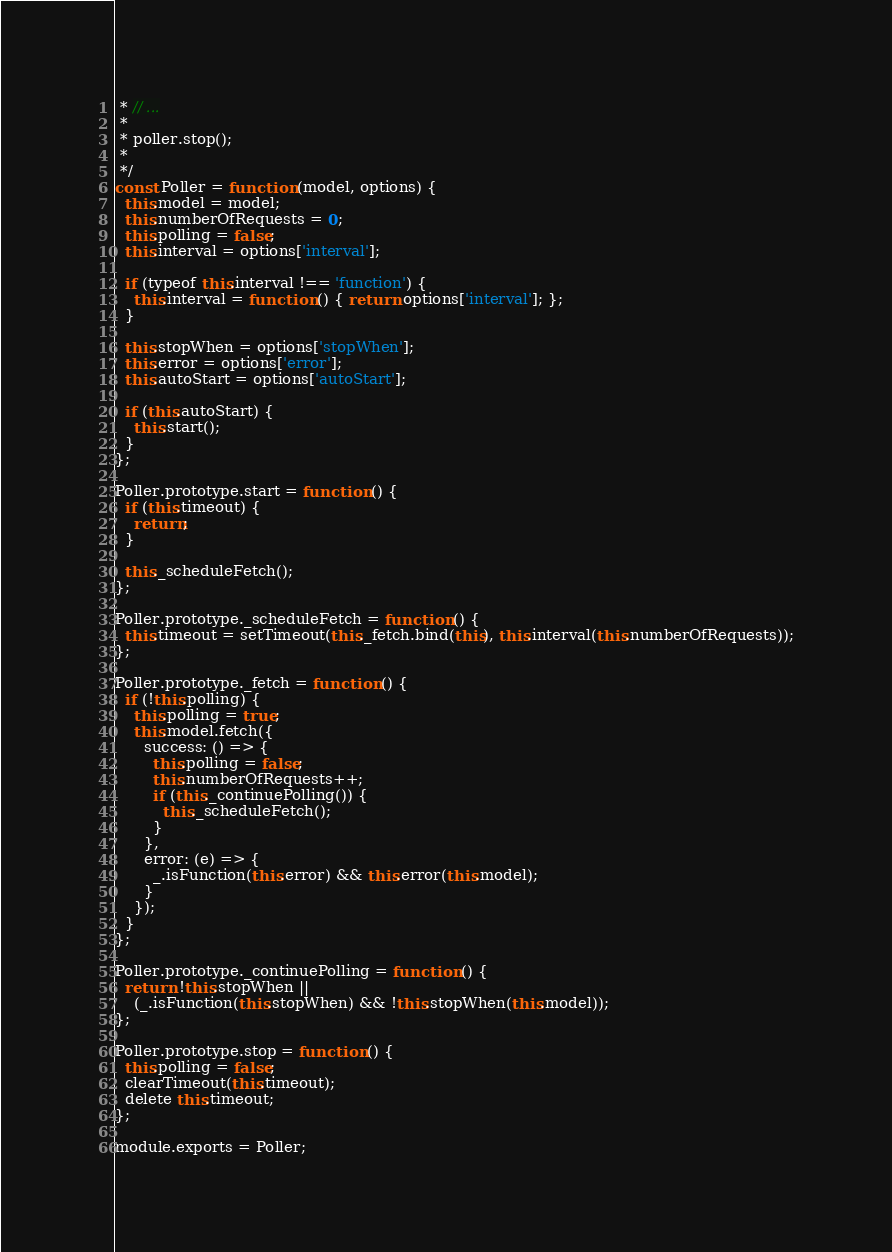<code> <loc_0><loc_0><loc_500><loc_500><_JavaScript_> * // ...
 *
 * poller.stop();
 *
 */
const Poller = function (model, options) {
  this.model = model;
  this.numberOfRequests = 0;
  this.polling = false;
  this.interval = options['interval'];

  if (typeof this.interval !== 'function') {
    this.interval = function () { return options['interval']; };
  }

  this.stopWhen = options['stopWhen'];
  this.error = options['error'];
  this.autoStart = options['autoStart'];

  if (this.autoStart) {
    this.start();
  }
};

Poller.prototype.start = function () {
  if (this.timeout) {
    return;
  }

  this._scheduleFetch();
};

Poller.prototype._scheduleFetch = function () {
  this.timeout = setTimeout(this._fetch.bind(this), this.interval(this.numberOfRequests));
};

Poller.prototype._fetch = function () {
  if (!this.polling) {
    this.polling = true;
    this.model.fetch({
      success: () => {
        this.polling = false;
        this.numberOfRequests++;
        if (this._continuePolling()) {
          this._scheduleFetch();
        }
      },
      error: (e) => {
        _.isFunction(this.error) && this.error(this.model);
      }
    });
  }
};

Poller.prototype._continuePolling = function () {
  return !this.stopWhen ||
    (_.isFunction(this.stopWhen) && !this.stopWhen(this.model));
};

Poller.prototype.stop = function () {
  this.polling = false;
  clearTimeout(this.timeout);
  delete this.timeout;
};

module.exports = Poller;
</code> 